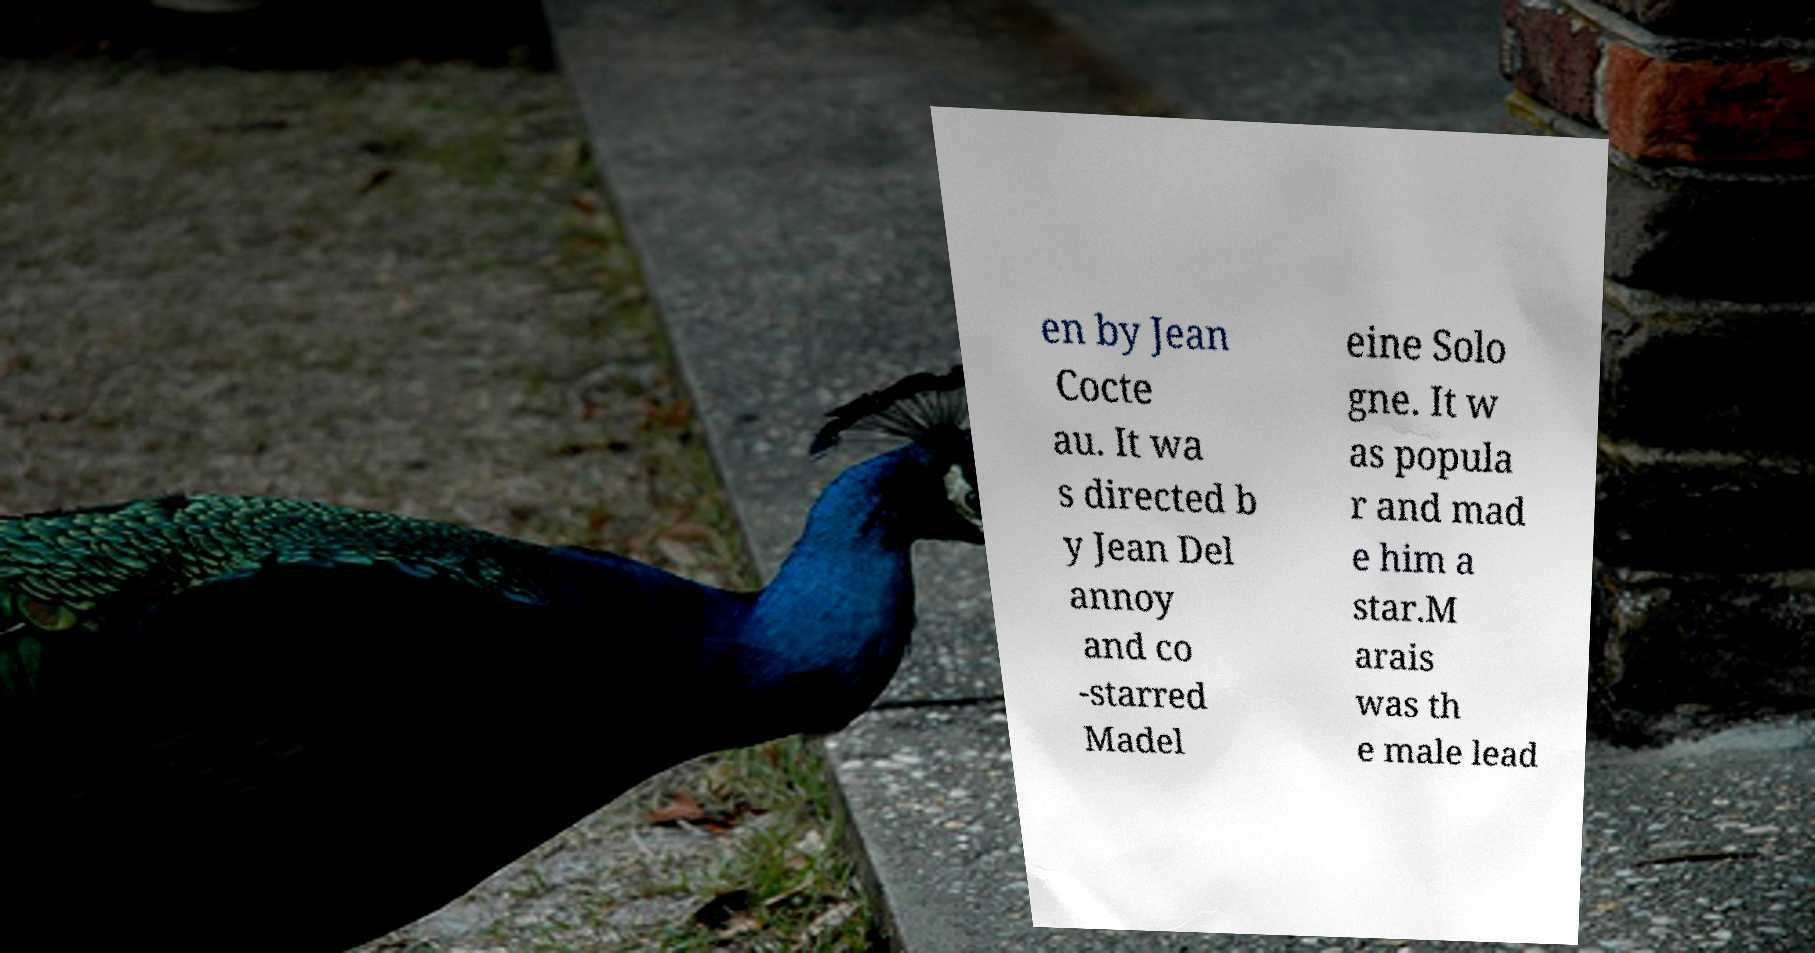Can you accurately transcribe the text from the provided image for me? en by Jean Cocte au. It wa s directed b y Jean Del annoy and co -starred Madel eine Solo gne. It w as popula r and mad e him a star.M arais was th e male lead 